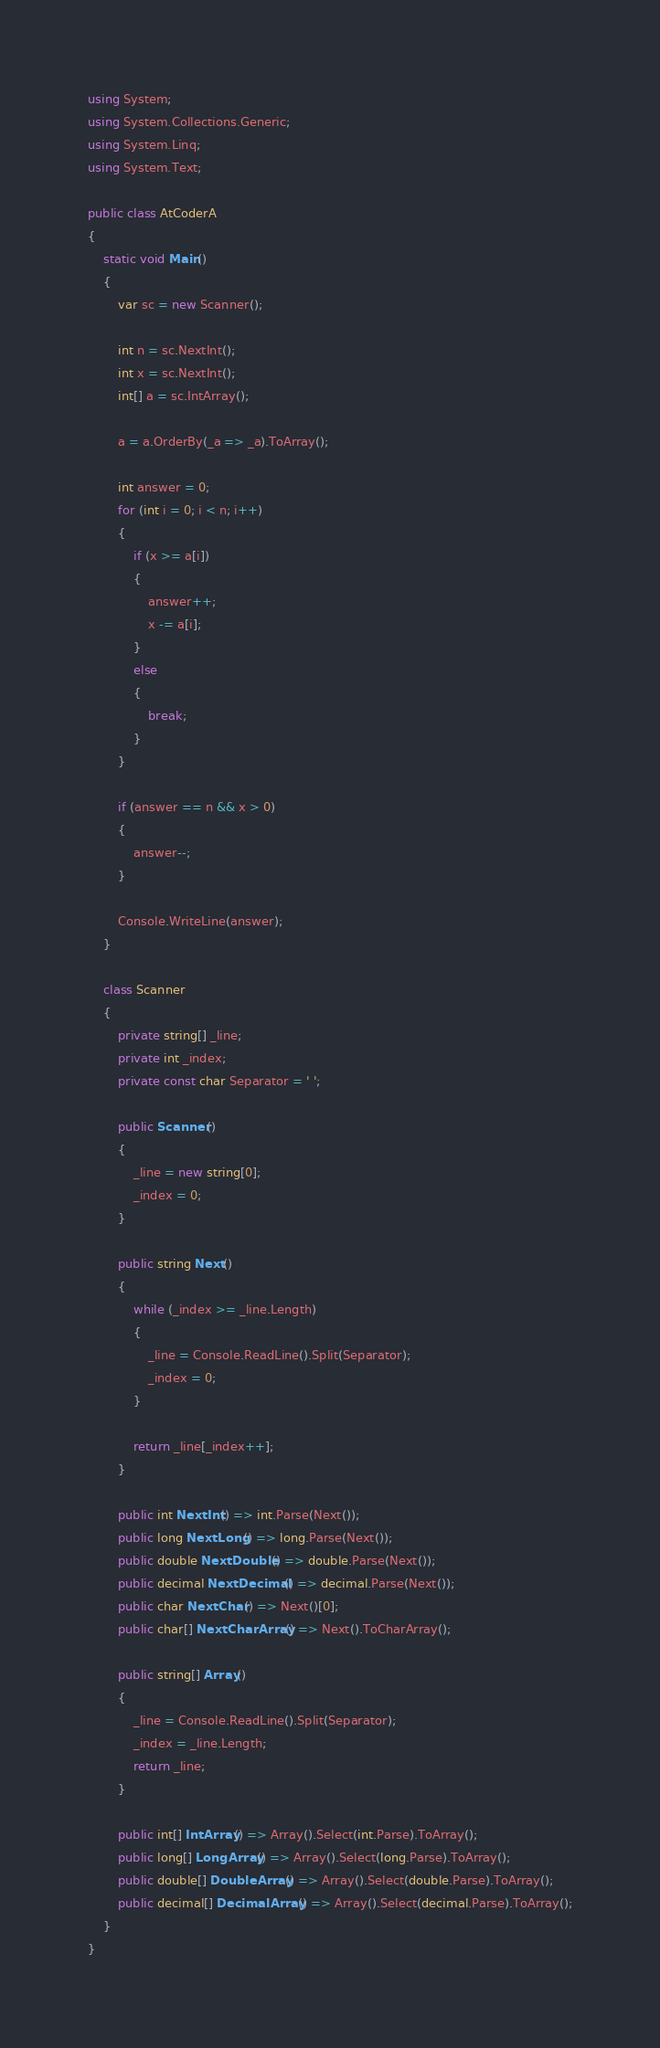Convert code to text. <code><loc_0><loc_0><loc_500><loc_500><_C#_>using System;
using System.Collections.Generic;
using System.Linq;
using System.Text;

public class AtCoderA
{
    static void Main()
    {
        var sc = new Scanner();

        int n = sc.NextInt();
        int x = sc.NextInt();
        int[] a = sc.IntArray();

        a = a.OrderBy(_a => _a).ToArray();

        int answer = 0;
        for (int i = 0; i < n; i++)
        {
            if (x >= a[i])
            {
                answer++;
                x -= a[i];
            }
            else
            {
                break;
            }
        }

        if (answer == n && x > 0)
        {
            answer--;
        }

        Console.WriteLine(answer);
    }

    class Scanner
    {
        private string[] _line;
        private int _index;
        private const char Separator = ' ';

        public Scanner()
        {
            _line = new string[0];
            _index = 0;
        }

        public string Next()
        {
            while (_index >= _line.Length)
            {
                _line = Console.ReadLine().Split(Separator);
                _index = 0;
            }

            return _line[_index++];
        }

        public int NextInt() => int.Parse(Next());
        public long NextLong() => long.Parse(Next());
        public double NextDouble() => double.Parse(Next());
        public decimal NextDecimal() => decimal.Parse(Next());
        public char NextChar() => Next()[0];
        public char[] NextCharArray() => Next().ToCharArray();

        public string[] Array()
        {
            _line = Console.ReadLine().Split(Separator);
            _index = _line.Length;
            return _line;
        }

        public int[] IntArray() => Array().Select(int.Parse).ToArray();
        public long[] LongArray() => Array().Select(long.Parse).ToArray();
        public double[] DoubleArray() => Array().Select(double.Parse).ToArray();
        public decimal[] DecimalArray() => Array().Select(decimal.Parse).ToArray();
    }
}</code> 